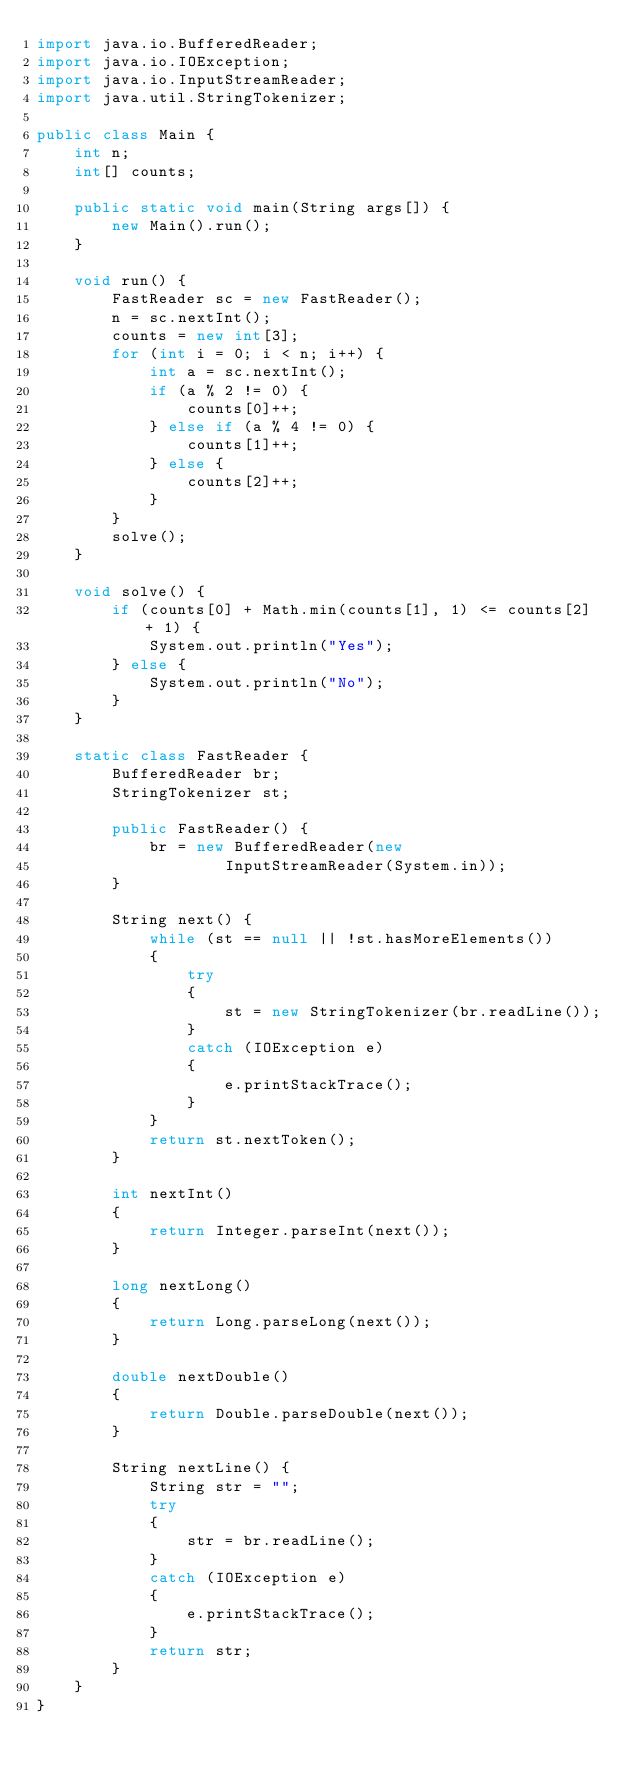<code> <loc_0><loc_0><loc_500><loc_500><_Java_>import java.io.BufferedReader;
import java.io.IOException;
import java.io.InputStreamReader;
import java.util.StringTokenizer;

public class Main {
    int n;
    int[] counts;

    public static void main(String args[]) {
        new Main().run();
    }

    void run() {
        FastReader sc = new FastReader();
        n = sc.nextInt();
        counts = new int[3];
        for (int i = 0; i < n; i++) {
            int a = sc.nextInt();
            if (a % 2 != 0) {
                counts[0]++;
            } else if (a % 4 != 0) {
                counts[1]++;
            } else {
                counts[2]++;
            }
        }
        solve();
    }

    void solve() {
        if (counts[0] + Math.min(counts[1], 1) <= counts[2] + 1) {
            System.out.println("Yes");
        } else {
            System.out.println("No");
        }
    }

    static class FastReader {
        BufferedReader br;
        StringTokenizer st;

        public FastReader() {
            br = new BufferedReader(new
                    InputStreamReader(System.in));
        }

        String next() {
            while (st == null || !st.hasMoreElements())
            {
                try
                {
                    st = new StringTokenizer(br.readLine());
                }
                catch (IOException e)
                {
                    e.printStackTrace();
                }
            }
            return st.nextToken();
        }

        int nextInt()
        {
            return Integer.parseInt(next());
        }

        long nextLong()
        {
            return Long.parseLong(next());
        }

        double nextDouble()
        {
            return Double.parseDouble(next());
        }

        String nextLine() {
            String str = "";
            try
            {
                str = br.readLine();
            }
            catch (IOException e)
            {
                e.printStackTrace();
            }
            return str;
        }
    }
}
</code> 